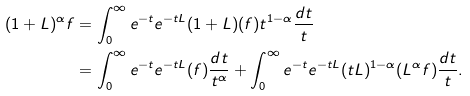<formula> <loc_0><loc_0><loc_500><loc_500>( 1 + L ) ^ { \alpha } f & = \int _ { 0 } ^ { \infty } e ^ { - t } e ^ { - t L } ( 1 + L ) ( f ) t ^ { 1 - \alpha } \frac { d t } { t } \\ & = \int _ { 0 } ^ { \infty } e ^ { - t } e ^ { - t L } ( f ) \frac { d t } { t ^ { \alpha } } + \int _ { 0 } ^ { \infty } e ^ { - t } e ^ { - t L } ( t L ) ^ { 1 - \alpha } ( L ^ { \alpha } f ) \frac { d t } { t } .</formula> 